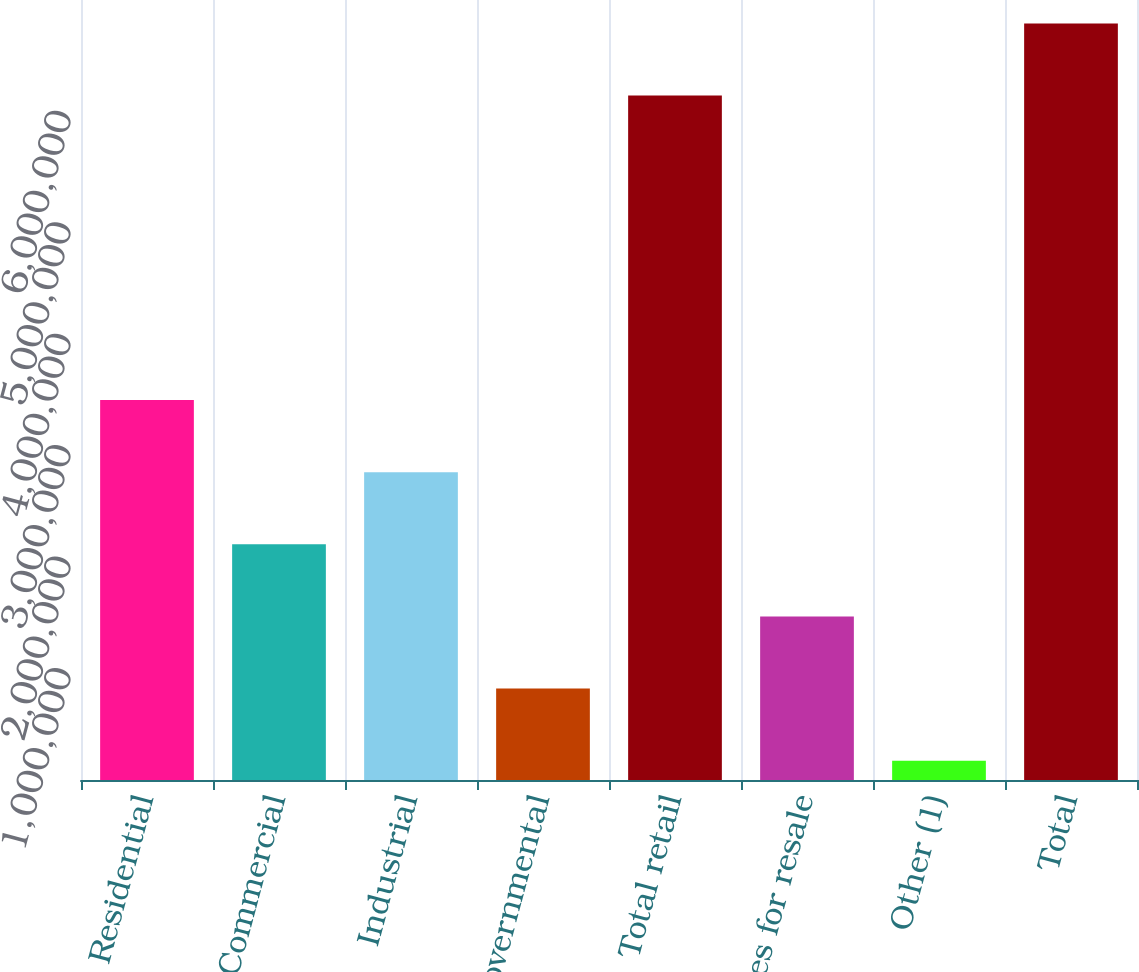Convert chart to OTSL. <chart><loc_0><loc_0><loc_500><loc_500><bar_chart><fcel>Residential<fcel>Commercial<fcel>Industrial<fcel>Governmental<fcel>Total retail<fcel>Sales for resale<fcel>Other (1)<fcel>Total<nl><fcel>3.41014e+06<fcel>2.11563e+06<fcel>2.76289e+06<fcel>821121<fcel>6.14254e+06<fcel>1.46838e+06<fcel>173866<fcel>6.78979e+06<nl></chart> 